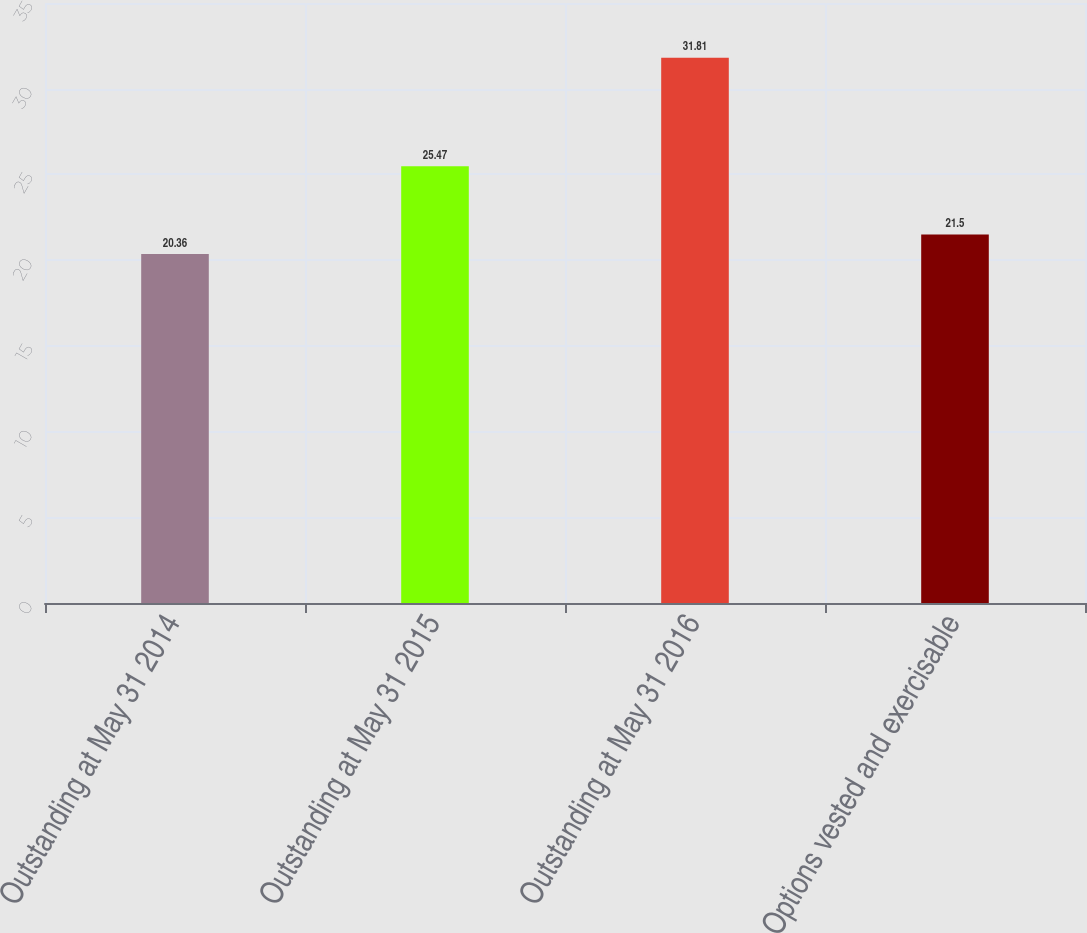Convert chart. <chart><loc_0><loc_0><loc_500><loc_500><bar_chart><fcel>Outstanding at May 31 2014<fcel>Outstanding at May 31 2015<fcel>Outstanding at May 31 2016<fcel>Options vested and exercisable<nl><fcel>20.36<fcel>25.47<fcel>31.81<fcel>21.5<nl></chart> 